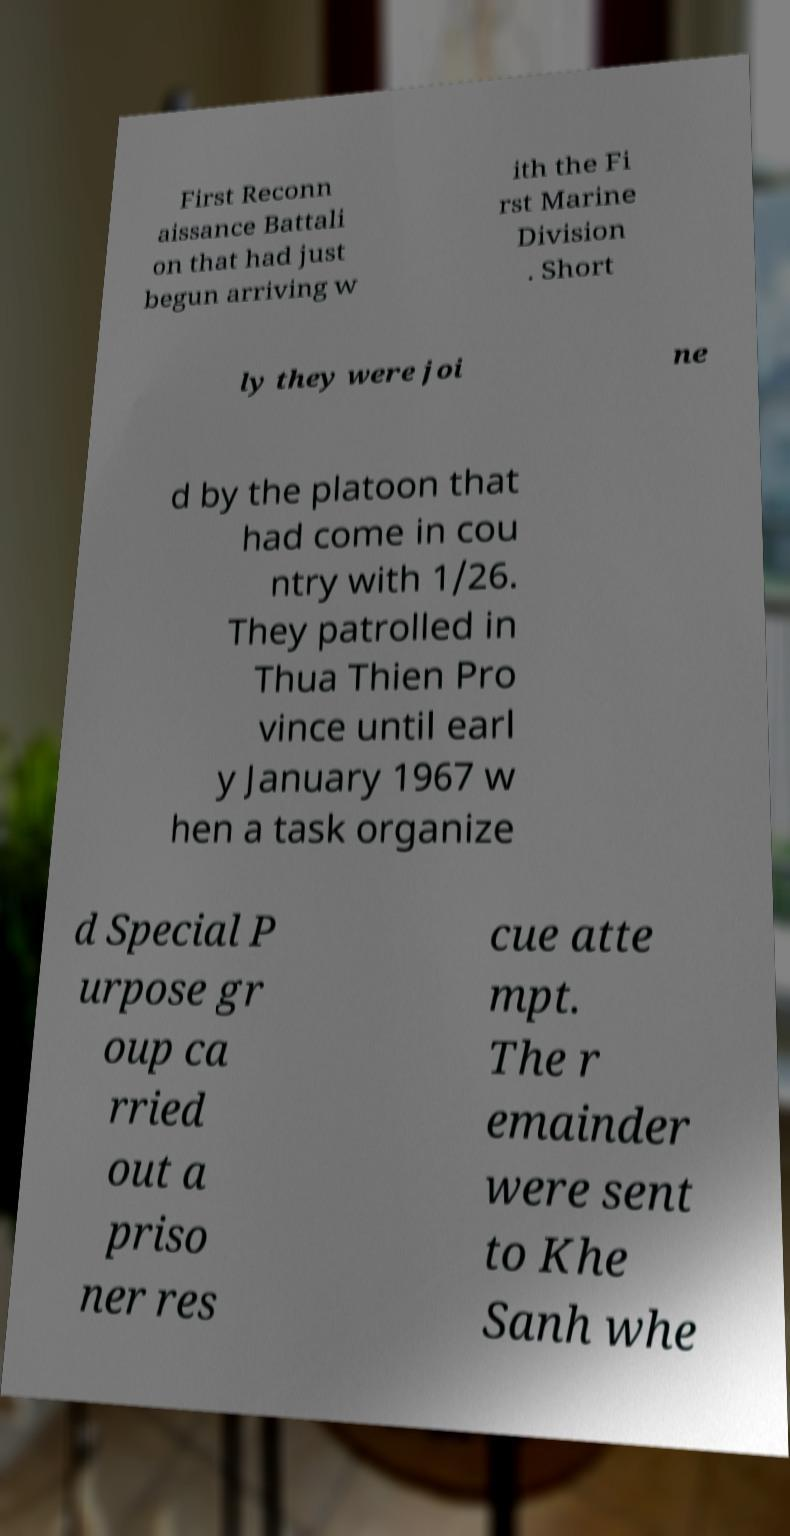Please read and relay the text visible in this image. What does it say? First Reconn aissance Battali on that had just begun arriving w ith the Fi rst Marine Division . Short ly they were joi ne d by the platoon that had come in cou ntry with 1/26. They patrolled in Thua Thien Pro vince until earl y January 1967 w hen a task organize d Special P urpose gr oup ca rried out a priso ner res cue atte mpt. The r emainder were sent to Khe Sanh whe 